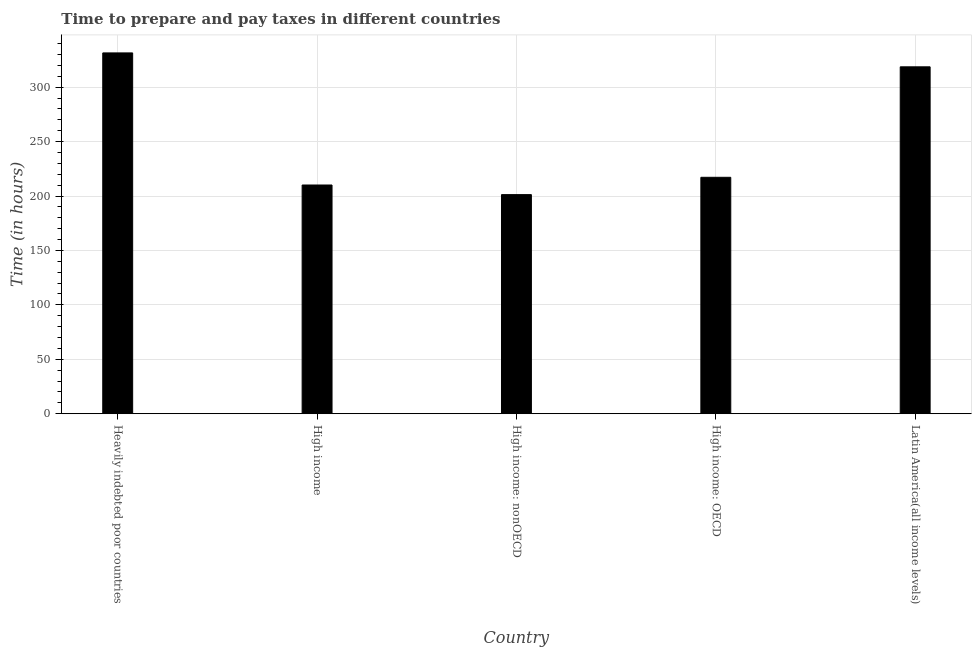What is the title of the graph?
Give a very brief answer. Time to prepare and pay taxes in different countries. What is the label or title of the X-axis?
Provide a short and direct response. Country. What is the label or title of the Y-axis?
Make the answer very short. Time (in hours). What is the time to prepare and pay taxes in Heavily indebted poor countries?
Provide a short and direct response. 331.47. Across all countries, what is the maximum time to prepare and pay taxes?
Offer a very short reply. 331.47. Across all countries, what is the minimum time to prepare and pay taxes?
Your answer should be compact. 201.29. In which country was the time to prepare and pay taxes maximum?
Provide a succinct answer. Heavily indebted poor countries. In which country was the time to prepare and pay taxes minimum?
Your answer should be compact. High income: nonOECD. What is the sum of the time to prepare and pay taxes?
Your response must be concise. 1278.79. What is the difference between the time to prepare and pay taxes in High income: OECD and High income: nonOECD?
Ensure brevity in your answer.  15.91. What is the average time to prepare and pay taxes per country?
Offer a terse response. 255.76. What is the median time to prepare and pay taxes?
Give a very brief answer. 217.2. What is the ratio of the time to prepare and pay taxes in High income to that in Latin America(all income levels)?
Offer a very short reply. 0.66. Is the time to prepare and pay taxes in Heavily indebted poor countries less than that in Latin America(all income levels)?
Provide a short and direct response. No. What is the difference between the highest and the second highest time to prepare and pay taxes?
Your response must be concise. 12.78. What is the difference between the highest and the lowest time to prepare and pay taxes?
Ensure brevity in your answer.  130.18. Are all the bars in the graph horizontal?
Make the answer very short. No. How many countries are there in the graph?
Make the answer very short. 5. What is the difference between two consecutive major ticks on the Y-axis?
Give a very brief answer. 50. Are the values on the major ticks of Y-axis written in scientific E-notation?
Offer a terse response. No. What is the Time (in hours) in Heavily indebted poor countries?
Offer a very short reply. 331.47. What is the Time (in hours) in High income?
Offer a terse response. 210.13. What is the Time (in hours) of High income: nonOECD?
Ensure brevity in your answer.  201.29. What is the Time (in hours) of High income: OECD?
Ensure brevity in your answer.  217.2. What is the Time (in hours) in Latin America(all income levels)?
Offer a very short reply. 318.69. What is the difference between the Time (in hours) in Heavily indebted poor countries and High income?
Make the answer very short. 121.34. What is the difference between the Time (in hours) in Heavily indebted poor countries and High income: nonOECD?
Your answer should be very brief. 130.18. What is the difference between the Time (in hours) in Heavily indebted poor countries and High income: OECD?
Your answer should be very brief. 114.27. What is the difference between the Time (in hours) in Heavily indebted poor countries and Latin America(all income levels)?
Provide a short and direct response. 12.78. What is the difference between the Time (in hours) in High income and High income: nonOECD?
Make the answer very short. 8.84. What is the difference between the Time (in hours) in High income and High income: OECD?
Keep it short and to the point. -7.07. What is the difference between the Time (in hours) in High income and Latin America(all income levels)?
Provide a short and direct response. -108.56. What is the difference between the Time (in hours) in High income: nonOECD and High income: OECD?
Offer a very short reply. -15.91. What is the difference between the Time (in hours) in High income: nonOECD and Latin America(all income levels)?
Give a very brief answer. -117.4. What is the difference between the Time (in hours) in High income: OECD and Latin America(all income levels)?
Your response must be concise. -101.49. What is the ratio of the Time (in hours) in Heavily indebted poor countries to that in High income?
Give a very brief answer. 1.58. What is the ratio of the Time (in hours) in Heavily indebted poor countries to that in High income: nonOECD?
Offer a very short reply. 1.65. What is the ratio of the Time (in hours) in Heavily indebted poor countries to that in High income: OECD?
Keep it short and to the point. 1.53. What is the ratio of the Time (in hours) in High income to that in High income: nonOECD?
Give a very brief answer. 1.04. What is the ratio of the Time (in hours) in High income to that in High income: OECD?
Provide a short and direct response. 0.97. What is the ratio of the Time (in hours) in High income to that in Latin America(all income levels)?
Provide a short and direct response. 0.66. What is the ratio of the Time (in hours) in High income: nonOECD to that in High income: OECD?
Make the answer very short. 0.93. What is the ratio of the Time (in hours) in High income: nonOECD to that in Latin America(all income levels)?
Keep it short and to the point. 0.63. What is the ratio of the Time (in hours) in High income: OECD to that in Latin America(all income levels)?
Offer a very short reply. 0.68. 